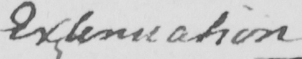Transcribe the text shown in this historical manuscript line. Extenuation 